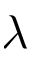<formula> <loc_0><loc_0><loc_500><loc_500>\lambda</formula> 